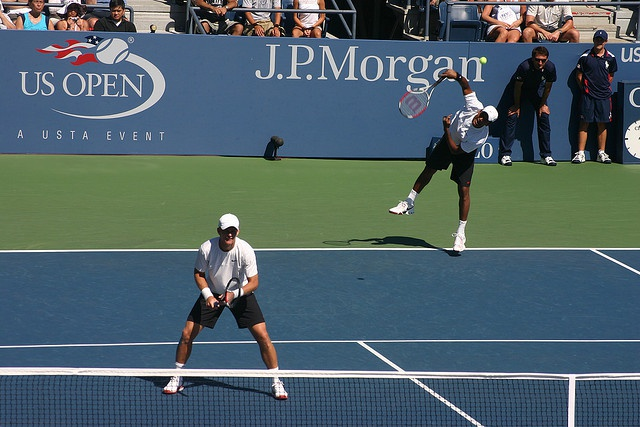Describe the objects in this image and their specific colors. I can see people in pink, black, white, gray, and darkgray tones, people in pink, black, gray, white, and maroon tones, people in pink, black, blue, navy, and gray tones, people in pink, black, navy, maroon, and salmon tones, and people in pink, black, darkgray, lightgray, and brown tones in this image. 